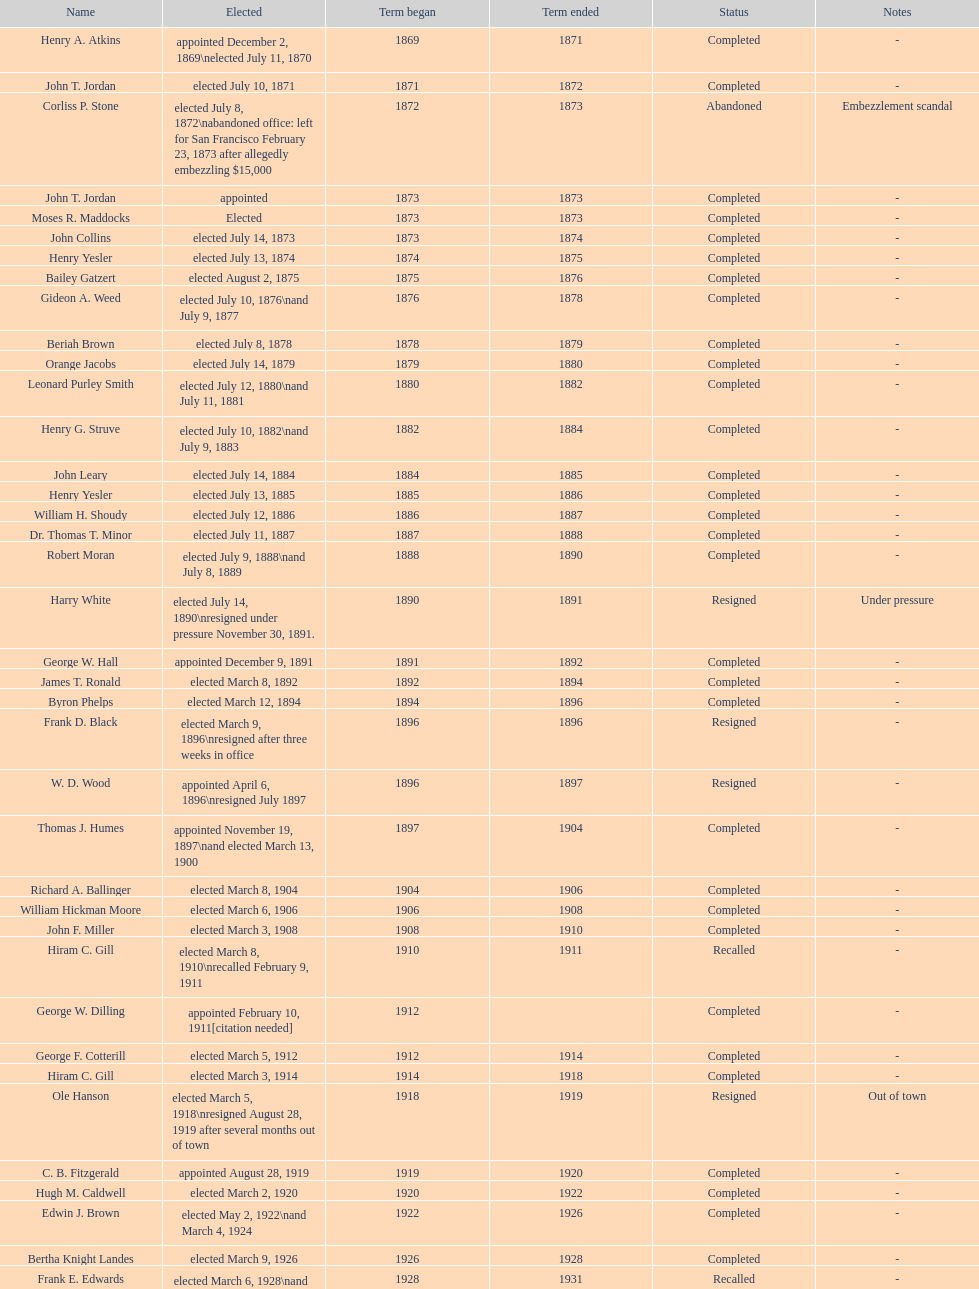During 1871, who was the only one that managed to get elected? John T. Jordan. 